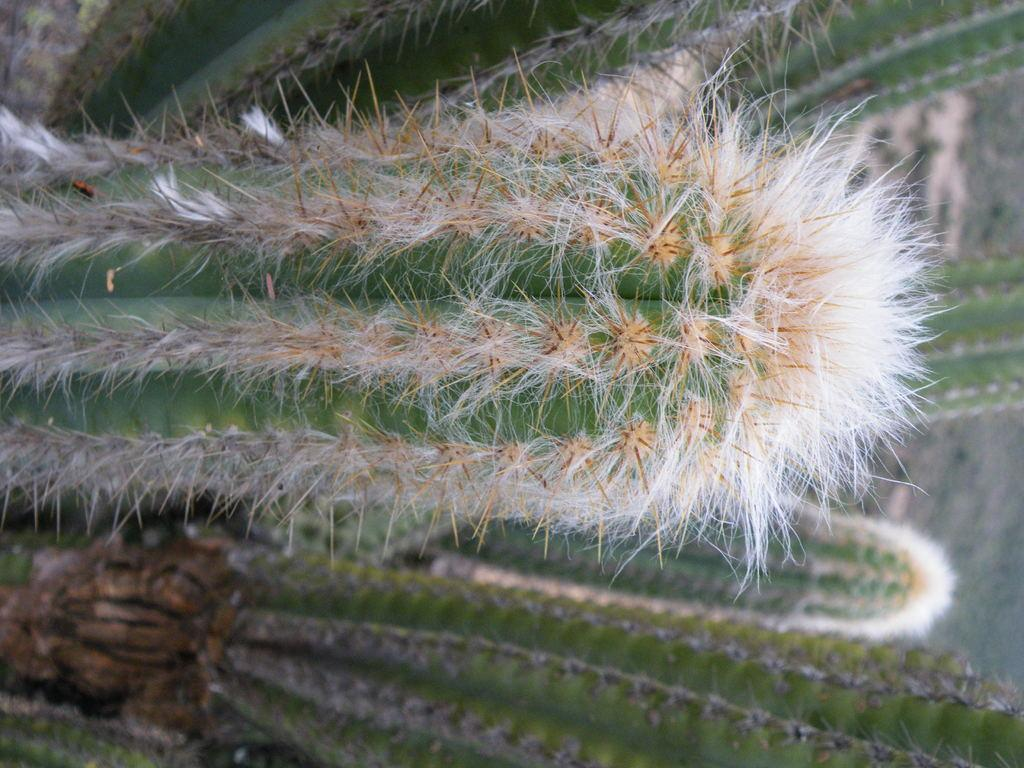What type of plants are in the image? There are cactus plants in the image. What feature do the cactus plants have? The cactus plants have spikes. What can be seen on the right side of the image? There is ground visible on the right side of the image. What type of butter can be seen melting on the cactus plants in the image? There is no butter present in the image; it features cactus plants with spikes. How many fowl are visible in the image? There are no fowl present in the image; it only features cactus plants and ground. 